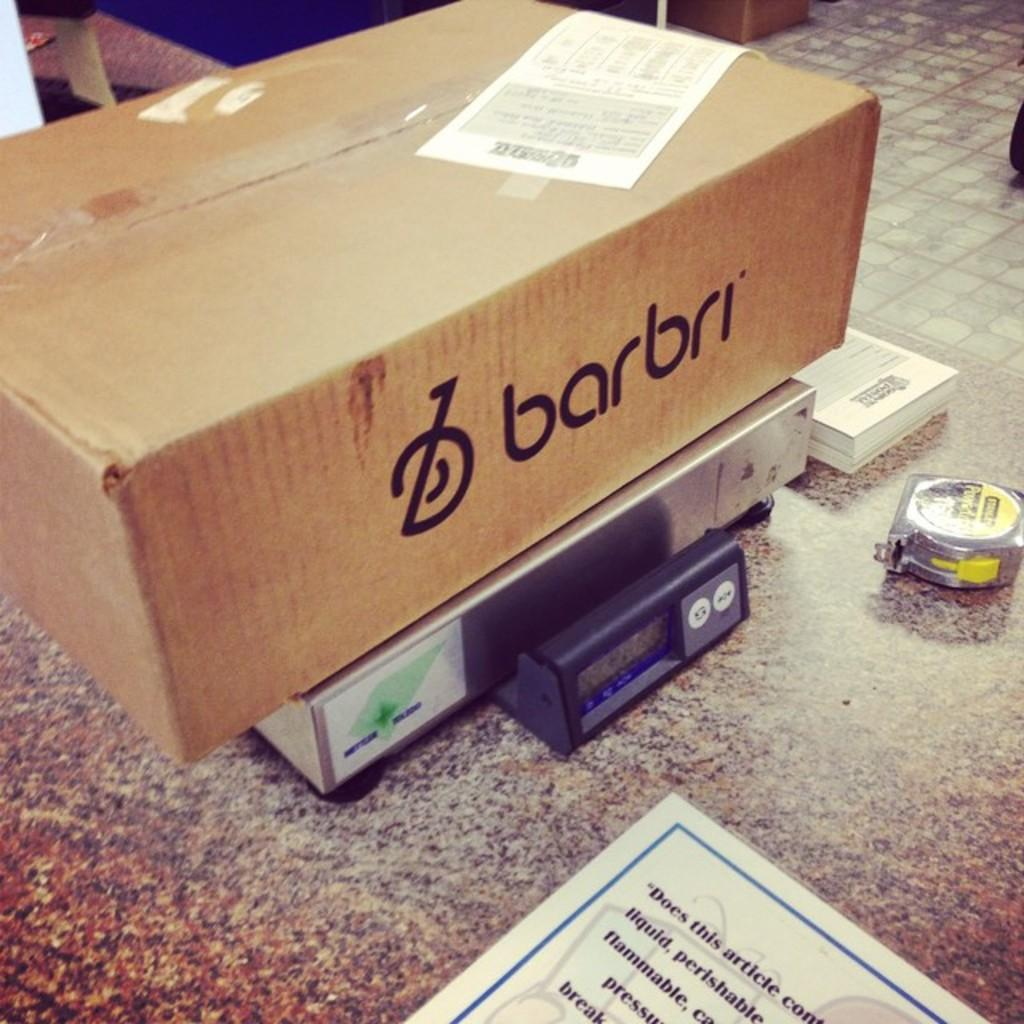<image>
Write a terse but informative summary of the picture. A box with barbri writting on the side sitting on a postal scale. 